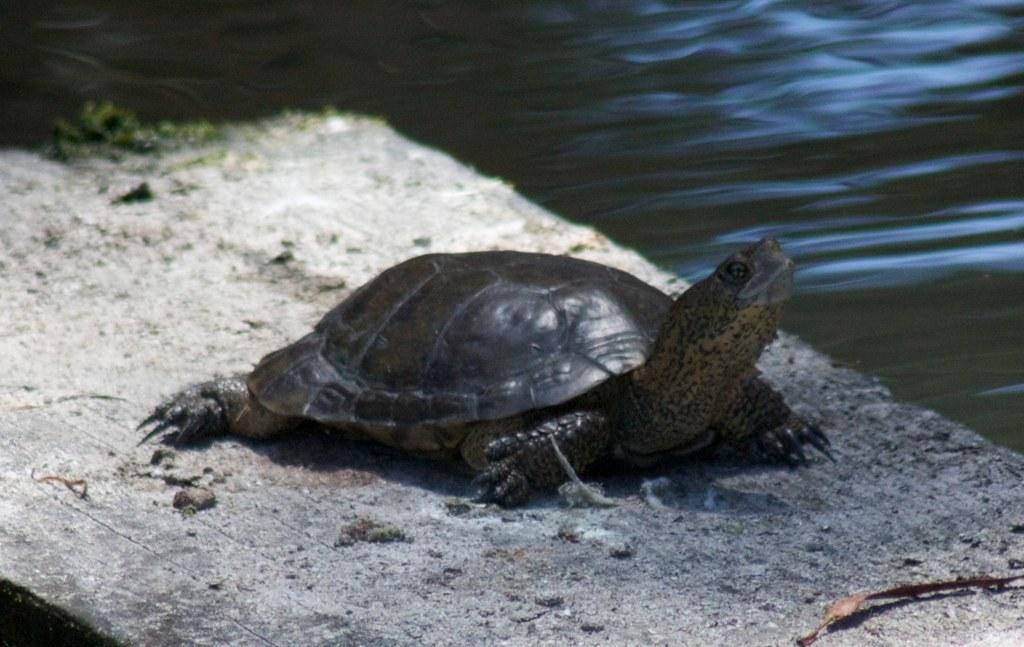What animal is present in the image? There is a tortoise in the image. What type of surface is the tortoise on? The tortoise is on a wooden surface. Can you describe the environment in the image? There is water visible in the image. How many brothers does the tortoise have in the image? There is no information about the tortoise having brothers in the image. 